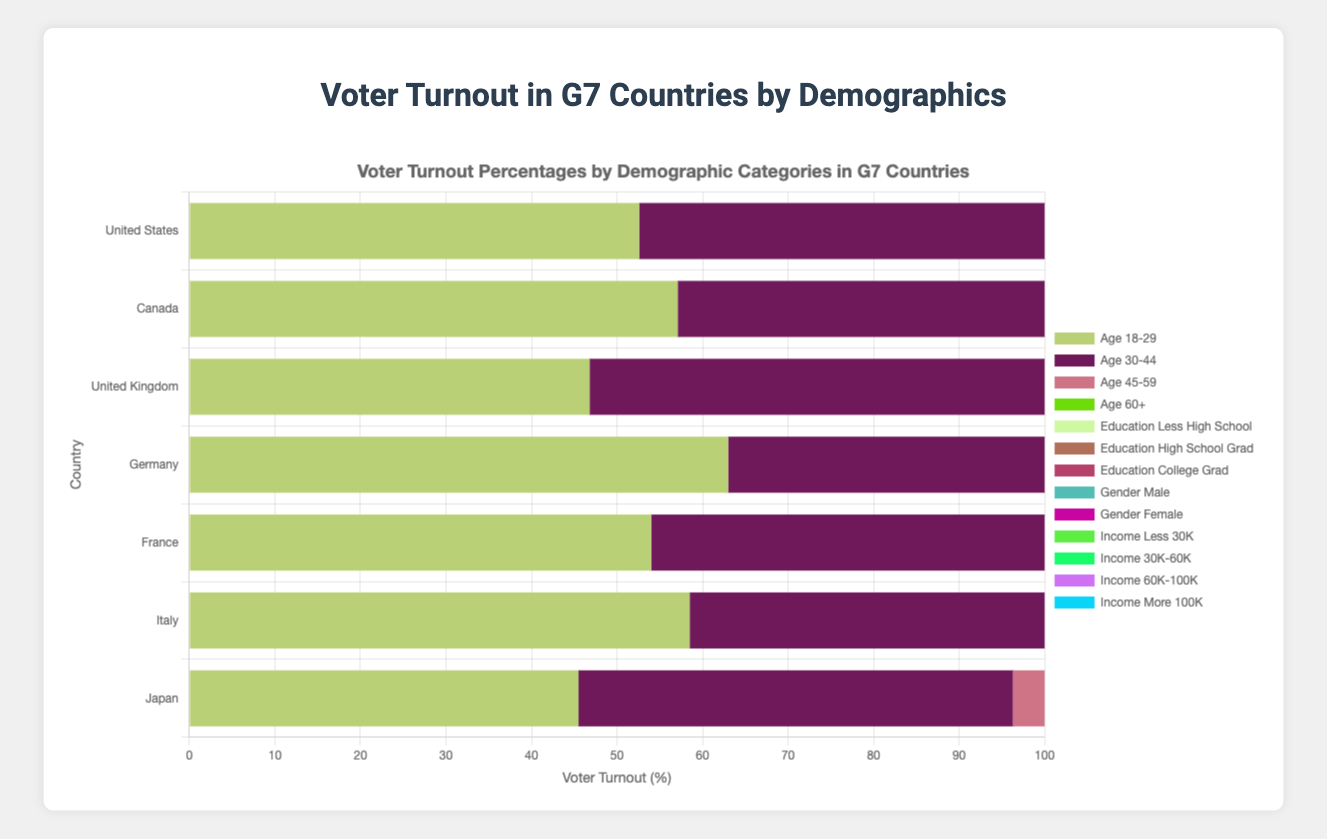Which G7 country has the highest voter turnout among the demographic category "Age 60+"? To answer this, look at the "Age 60+" bars for each country and identify the one that's longest. Germany has the longest bar for "Age 60+", indicating the highest turnout.
Answer: Germany What is the difference in voter turnout between the "Age 18-29" and "Age 60+" demographic categories in Japan? To calculate this, subtract the "Age 18-29" percentage (45.5%) from the "Age 60+" percentage (66.6%). The calculation is 66.6 - 45.5 = 21.1.
Answer: 21.1% Which gender has a higher voter turnout in Italy? Compare the lengths of the bars for "Gender_Male" and "Gender_Female" in Italy; "Gender_Female" is longer.
Answer: Female What is the average voter turnout for the "Education_College_Grad" demographic across all G7 countries? Sum the voter turnout percentages for "Education_College_Grad" across all countries: 69.8 + 72.2 + 66.1 + 77.0 + 71.5 + 75.1 + 66.3 = 498. Divide by the number of countries (7): 498 / 7 = 71.14.
Answer: 71.14% In which G7 country is the voter turnout for "Income_Less_30K" the lowest? Look for the shortest "Income_Less_30K" bars across all countries; the United Kingdom has the shortest bar.
Answer: United Kingdom How does the voter turnout for "Education_Less_High_School" in France compare to that in the United States? Compare the lengths of the "Education_Less_High_School" bars for France (50.4) and the United States (50.2).
Answer: France has a slightly higher turnout than the United States What is the overall difference in voter turnout between the highest and lowest turnout demographic categories in the United States? Identify the highest (Age_60+ at 74.6) and lowest (Income_Less_30K at 47.9) categories. Calculate the difference: 74.6 - 47.9 = 26.7.
Answer: 26.7% Which country has the most significant discrepancy between male and female voter turnout? Calculate the differences between "Gender_Male" and "Gender_Female" for each country. The United States has the most significant discrepancy: 64.3 - 60.1 = 4.2.
Answer: United States For the "Income_60K-100K" demographic, which country shows the highest voter turnout? Look at the "Income_60K-100K" bars and find the longest one; Germany has the highest turnout with a percentage of 73.5.
Answer: Germany 